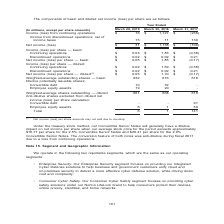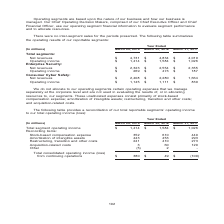From Nortonlifelock's financial document, What are the two reportable segments? The document shows two values: Enterprise Security and Consumer Cyber Safety. From the document: "• Enterprise Security. Our Enterprise Security segment focuses on providing our Integrated Cyber Defense solutions to hel • Enterprise Security. Our E..." Also, What does the table represent? summarizes the operating results of our reportable segments. The document states: "es for the periods presented. The following table summarizes the operating results of our reportable segments:..." Also, What is the total segments operating income for Year ended  March 29, 2019? According to the financial document, $1,414 (in millions). The relevant text states: "venues $ 4,731 $ 4,834 $ 4,019 Operating income $ 1,414 $ 1,584 $ 1,026 Enterprise Security: Net revenues $ 2,323 $ 2,554 $ 2,355 Operating income $ 269 $..." Also, can you calculate: What is the average total segments Operating income for the fiscal years 2019, 2018 and 2017? To answer this question, I need to perform calculations using the financial data. The calculation is: (1,414+1,584+1,026)/3, which equals 1341.33 (in millions). This is based on the information: "4,834 $ 4,019 Operating income $ 1,414 $ 1,584 $ 1,026 Enterprise Security: Net revenues $ 2,323 $ 2,554 $ 2,355 Operating income $ 269 $ 473 $ 187 Consum venues $ 4,731 $ 4,834 $ 4,019 Operating inco..." The key data points involved are: 1,026, 1,414, 1,584. Also, can you calculate: What is the average total segments Net revenues for the fiscal years 2019, 2018 and 2017? To answer this question, I need to perform calculations using the financial data. The calculation is: (4,731+4,834+4,019)/3, which equals 4528 (in millions). This is based on the information: "Total segments: Net revenues $ 4,731 $ 4,834 $ 4,019 Operating income $ 1,414 $ 1,584 $ 1,026 Enterprise Security: Net revenues $ 2,323 Total segments: Net revenues $ 4,731 $ 4,834 $ 4,019 Operating i..." The key data points involved are: 4,019, 4,731, 4,834. Also, can you calculate: For fiscal year 2019, what is the total segements Operating income expressed as a percentage of net revenues? Based on the calculation: 1,414/4,731, the result is 29.89 (percentage). This is based on the information: "Total segments: Net revenues $ 4,731 $ 4,834 $ 4,019 Operating income $ 1,414 $ 1,584 $ 1,026 Enterprise Security: Net revenues $ 2,323 venues $ 4,731 $ 4,834 $ 4,019 Operating income $ 1,414 $ 1,584 ..." The key data points involved are: 1,414, 4,731. 